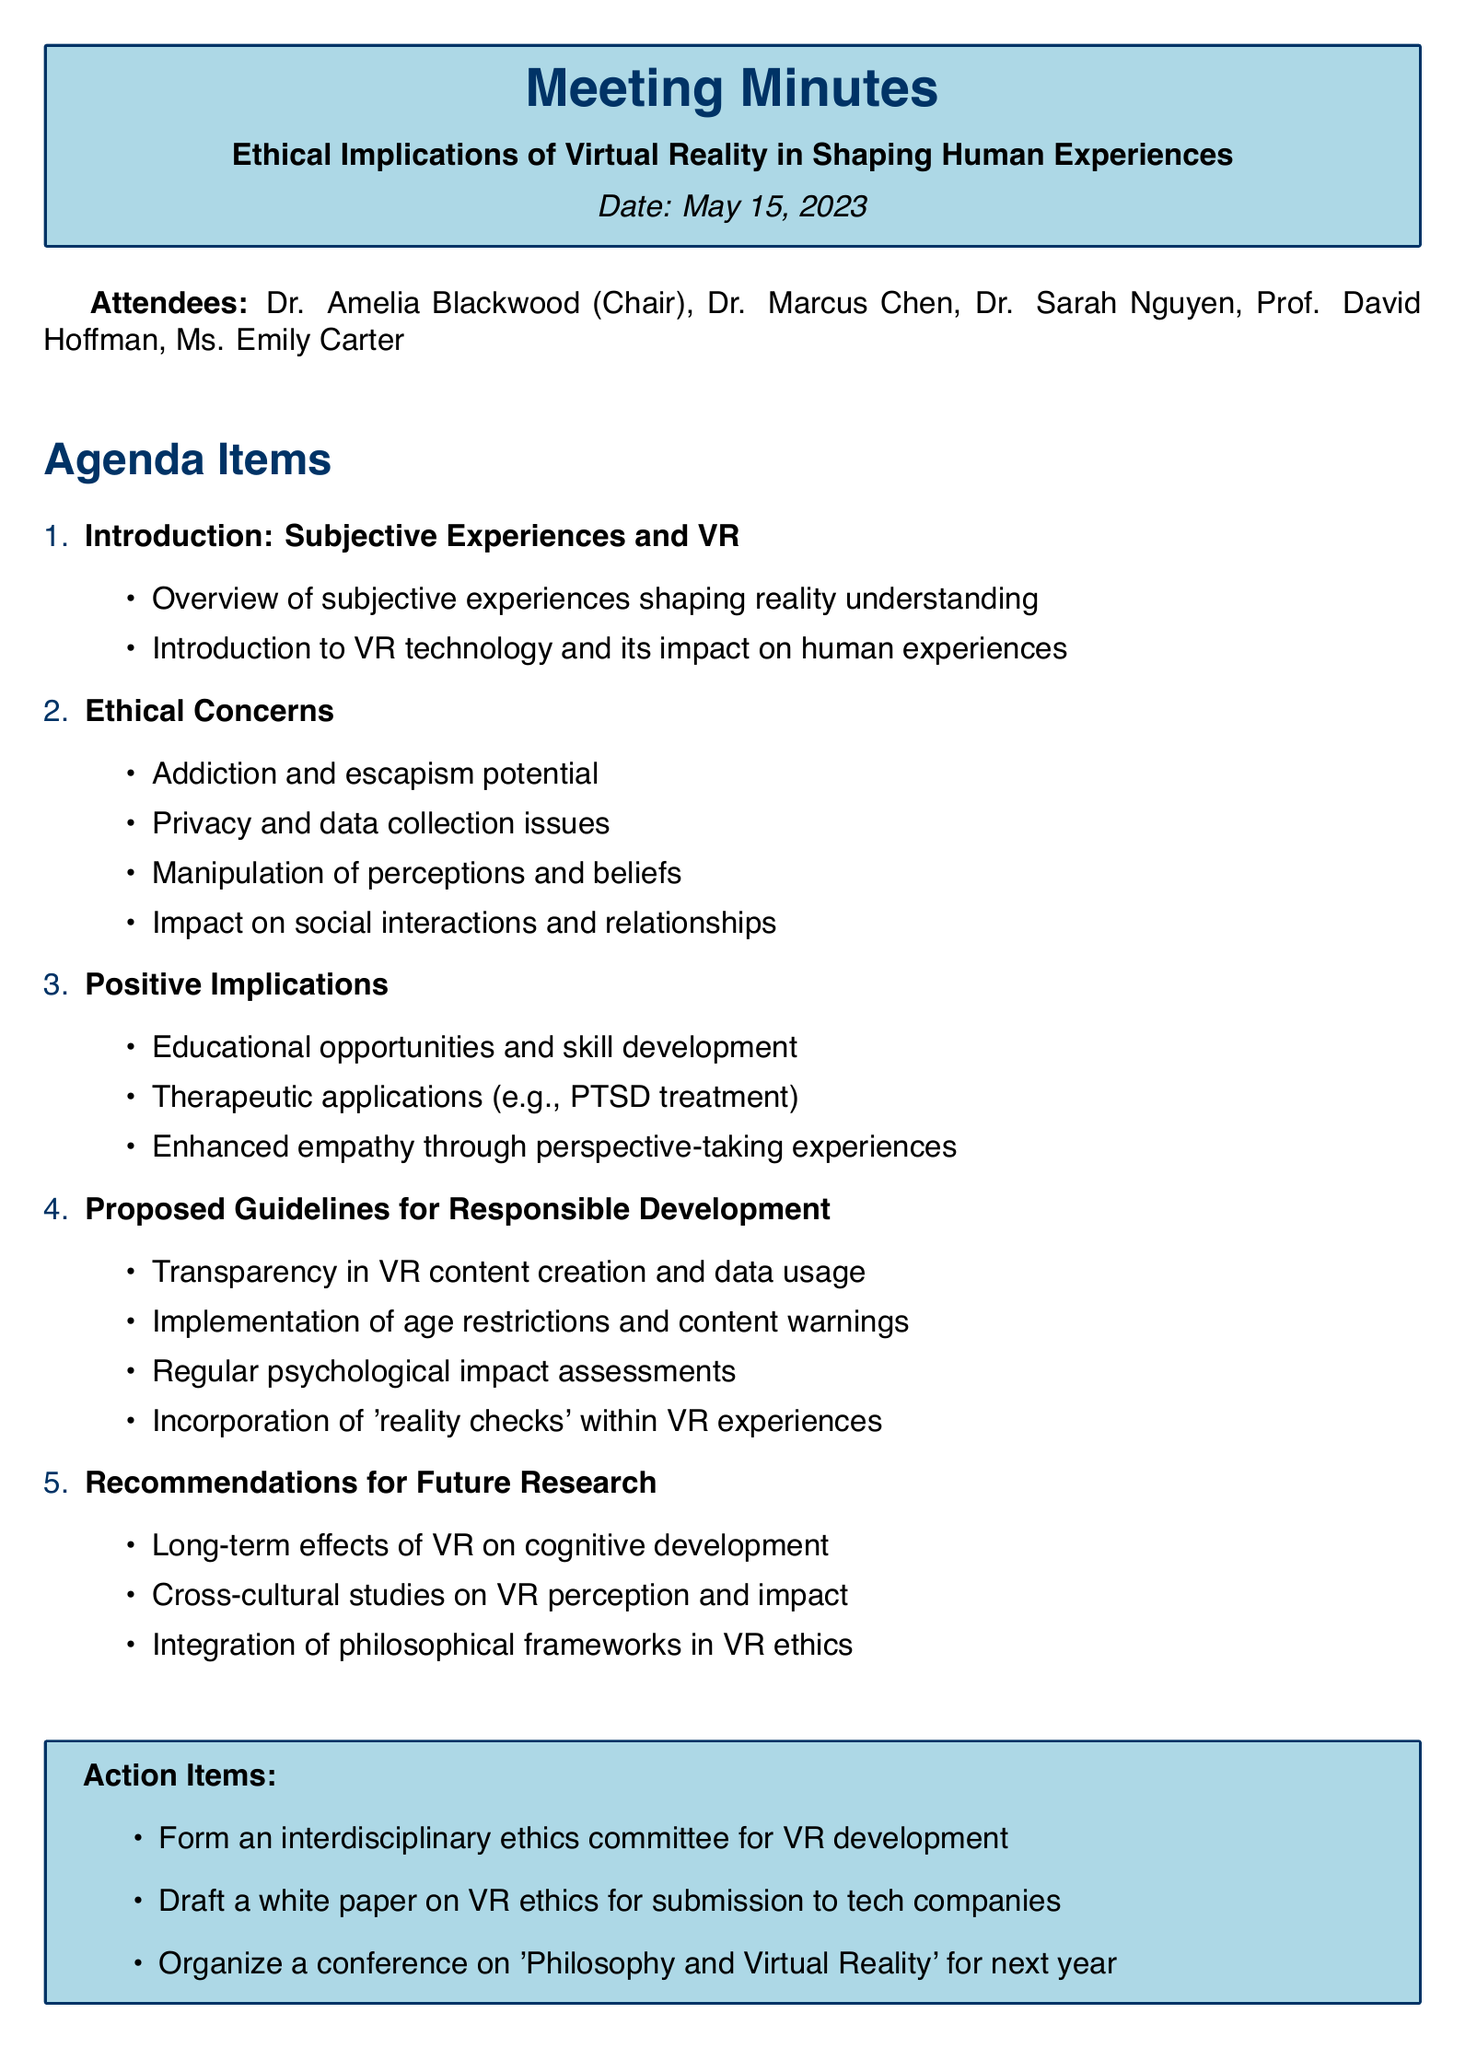What is the date of the meeting? The date of the meeting is specified in the document.
Answer: May 15, 2023 Who is the Chair of the meeting? The attendees' list includes the title and names of the participants.
Answer: Dr. Amelia Blackwood What is one ethical concern mentioned in the document? The agenda item on ethical concerns lists specific issues in VR.
Answer: Privacy and data collection issues What are the proposed guidelines for responsible development? The document outlines several proposed guidelines in a specific section.
Answer: Transparency in VR content creation and data usage What is one positive implication of VR technology? The document lists potential positive implications under that agenda item.
Answer: Educational opportunities and skill development What actions are recommended for the future? The document specifies action items to be taken after the meeting.
Answer: Form an interdisciplinary ethics committee for VR development How many attendees were present at the meeting? The number of attendees can be counted in the list provided.
Answer: Five What is the title of the meeting? The title is prominently displayed near the beginning of the document.
Answer: Ethical Implications of Virtual Reality in Shaping Human Experiences 